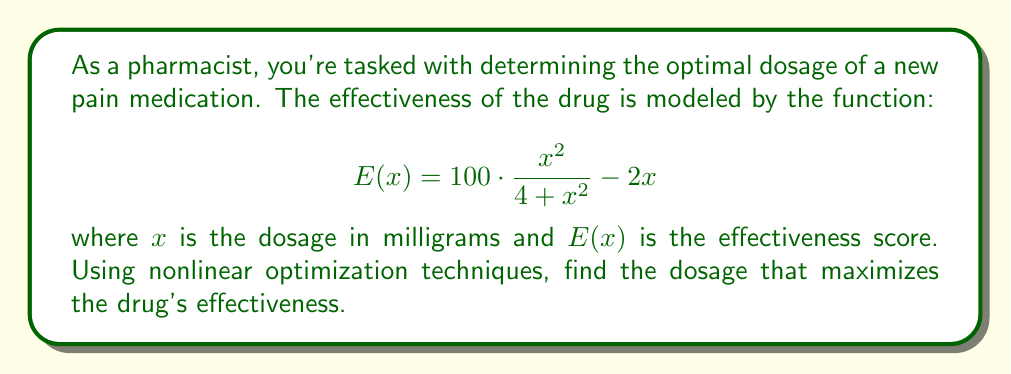Help me with this question. To find the optimal dosage, we need to maximize the effectiveness function $E(x)$. This is a nonlinear optimization problem. We'll solve it using the following steps:

1) First, we need to find the critical points by taking the derivative of $E(x)$ and setting it equal to zero:

   $$E'(x) = 100 \cdot \frac{2x(4+x^2) - 2x^3}{(4+x^2)^2} - 2$$
   
   $$E'(x) = \frac{200x + 200x^3 - 200x^3}{(4+x^2)^2} - 2$$
   
   $$E'(x) = \frac{200x}{(4+x^2)^2} - 2$$

2) Set $E'(x) = 0$ and solve:

   $$\frac{200x}{(4+x^2)^2} - 2 = 0$$
   
   $$\frac{200x}{(4+x^2)^2} = 2$$
   
   $$200x = 2(4+x^2)^2$$
   
   $$100x = (4+x^2)^2$$
   
   $$10\sqrt{x} = 4+x^2$$

3) This equation can't be solved algebraically. We need to use numerical methods. Using a graphing calculator or computer software, we find that this equation has two positive solutions: approximately 0.4142 and 2.4142.

4) To determine which of these is the maximum, we can evaluate $E(x)$ at both points:

   $E(0.4142) \approx 16.5858$
   $E(2.4142) \approx 38.1966$

5) We can also check the endpoints:

   $E(0) = 0$
   $\lim_{x \to \infty} E(x) = -\infty$

Therefore, the maximum occurs at $x \approx 2.4142$.
Answer: $2.4142$ mg 